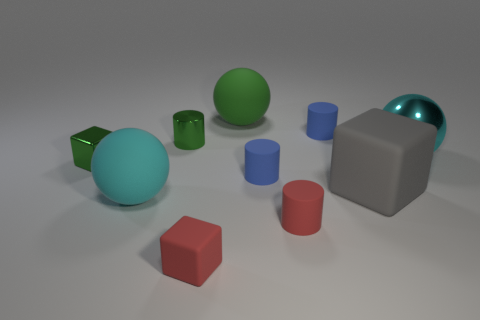Subtract all cubes. How many objects are left? 7 Subtract 2 cyan spheres. How many objects are left? 8 Subtract all shiny cylinders. Subtract all shiny cylinders. How many objects are left? 8 Add 3 small blue rubber things. How many small blue rubber things are left? 5 Add 3 tiny green cylinders. How many tiny green cylinders exist? 4 